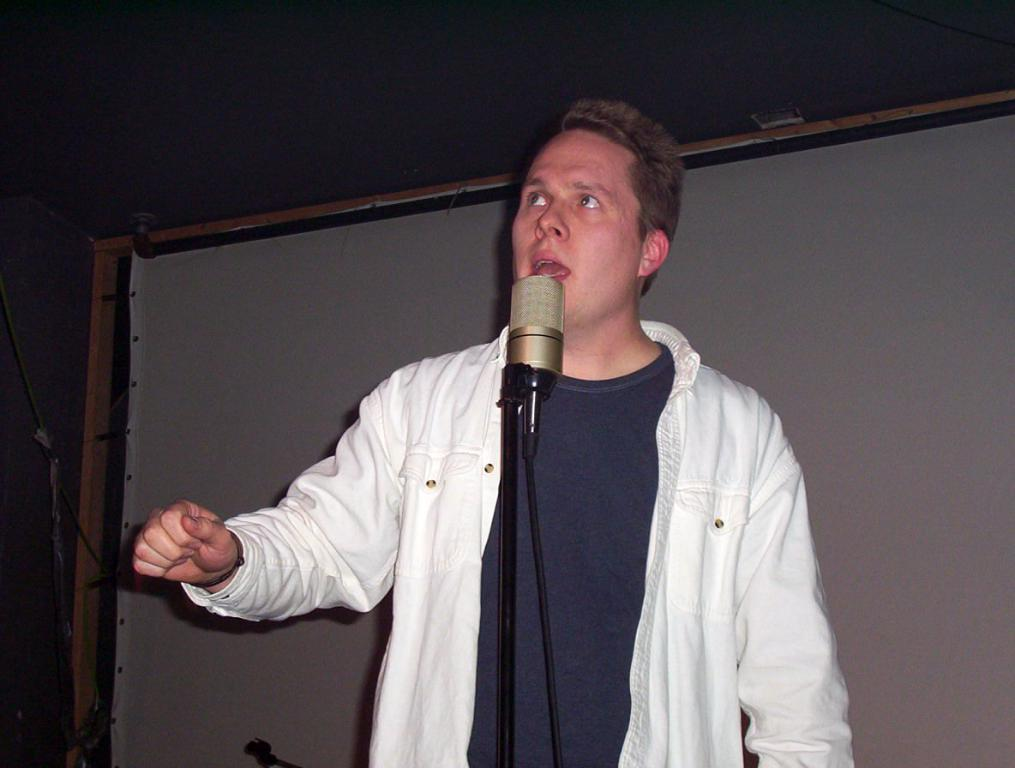What is the person in the image doing? The person is standing in the image. What is the person wearing? The person is wearing a white shirt. What object is in front of the person? There is a microphone in front of the person. What can be seen in the background of the image? There is a white board in the background of the image. What type of lettuce is being used to hold the microphone in place? There is no lettuce present in the image, and the microphone is not being held in place by any lettuce. 